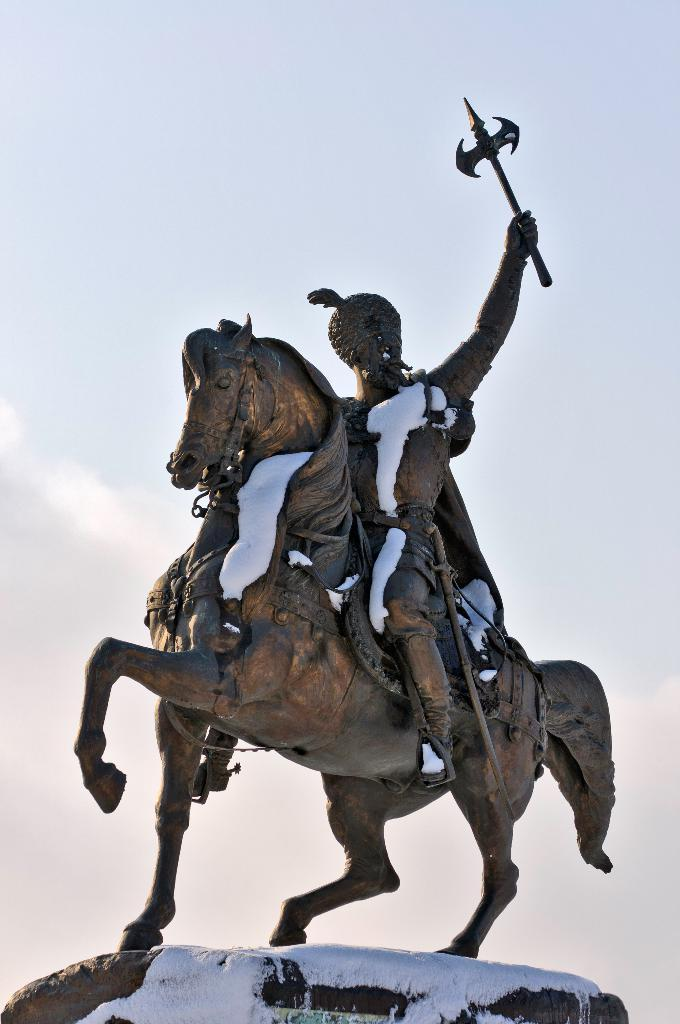What is the main subject of the image? There is a statue of a person on a horse in the image. How is the statue positioned in the image? The statue is on a pedestal. What can be seen in the background of the image? There is sky visible in the background of the image. How many chickens are perched on the statue's head in the image? There are no chickens present in the image; it features a statue of a person on a horse. What type of cabbage is growing on the pedestal in the image? There is no cabbage present in the image; the statue is on a pedestal without any vegetation. 